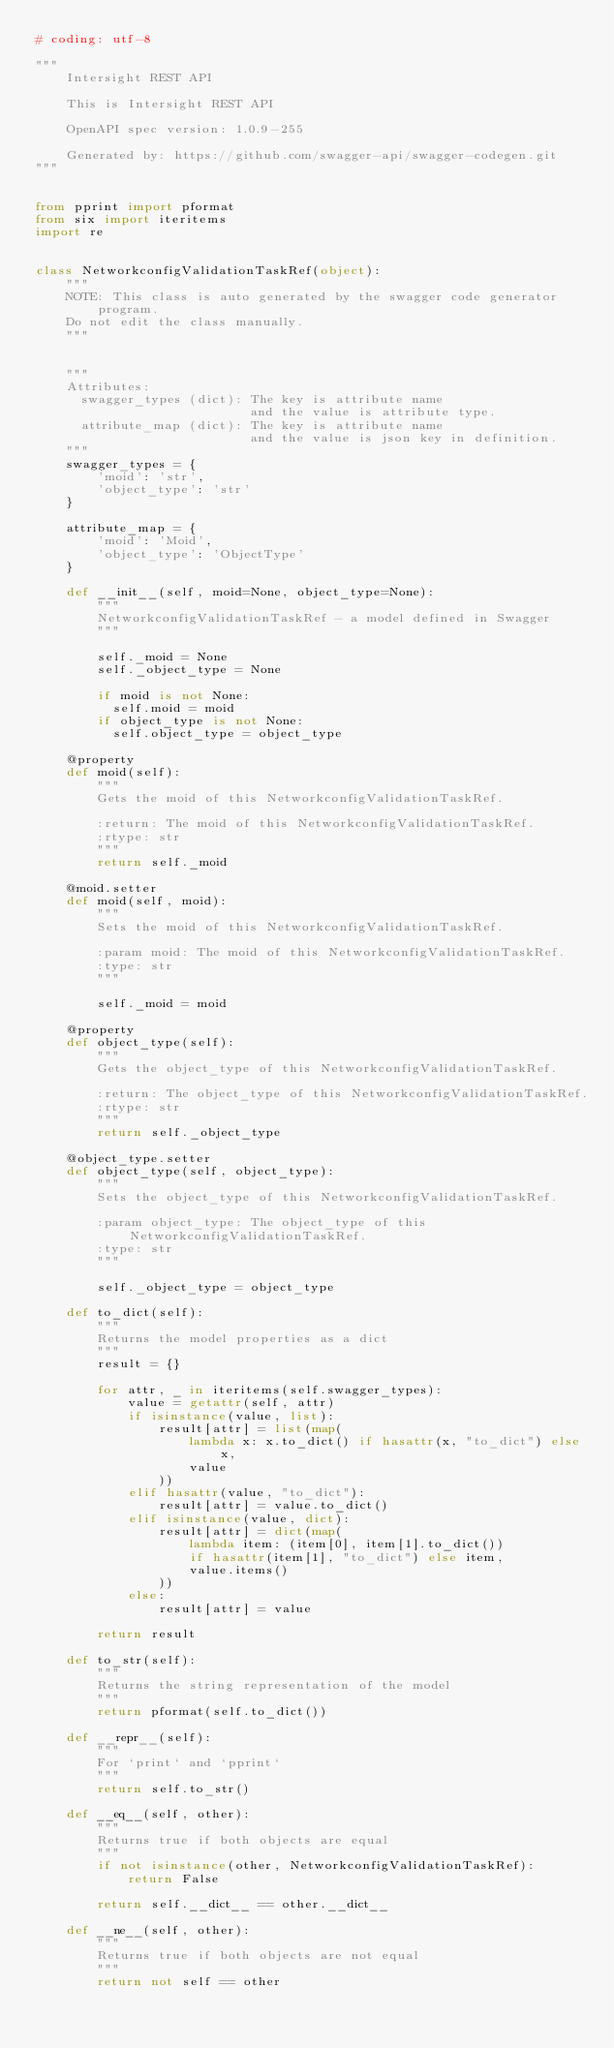Convert code to text. <code><loc_0><loc_0><loc_500><loc_500><_Python_># coding: utf-8

"""
    Intersight REST API

    This is Intersight REST API 

    OpenAPI spec version: 1.0.9-255
    
    Generated by: https://github.com/swagger-api/swagger-codegen.git
"""


from pprint import pformat
from six import iteritems
import re


class NetworkconfigValidationTaskRef(object):
    """
    NOTE: This class is auto generated by the swagger code generator program.
    Do not edit the class manually.
    """


    """
    Attributes:
      swagger_types (dict): The key is attribute name
                            and the value is attribute type.
      attribute_map (dict): The key is attribute name
                            and the value is json key in definition.
    """
    swagger_types = {
        'moid': 'str',
        'object_type': 'str'
    }

    attribute_map = {
        'moid': 'Moid',
        'object_type': 'ObjectType'
    }

    def __init__(self, moid=None, object_type=None):
        """
        NetworkconfigValidationTaskRef - a model defined in Swagger
        """

        self._moid = None
        self._object_type = None

        if moid is not None:
          self.moid = moid
        if object_type is not None:
          self.object_type = object_type

    @property
    def moid(self):
        """
        Gets the moid of this NetworkconfigValidationTaskRef.

        :return: The moid of this NetworkconfigValidationTaskRef.
        :rtype: str
        """
        return self._moid

    @moid.setter
    def moid(self, moid):
        """
        Sets the moid of this NetworkconfigValidationTaskRef.

        :param moid: The moid of this NetworkconfigValidationTaskRef.
        :type: str
        """

        self._moid = moid

    @property
    def object_type(self):
        """
        Gets the object_type of this NetworkconfigValidationTaskRef.

        :return: The object_type of this NetworkconfigValidationTaskRef.
        :rtype: str
        """
        return self._object_type

    @object_type.setter
    def object_type(self, object_type):
        """
        Sets the object_type of this NetworkconfigValidationTaskRef.

        :param object_type: The object_type of this NetworkconfigValidationTaskRef.
        :type: str
        """

        self._object_type = object_type

    def to_dict(self):
        """
        Returns the model properties as a dict
        """
        result = {}

        for attr, _ in iteritems(self.swagger_types):
            value = getattr(self, attr)
            if isinstance(value, list):
                result[attr] = list(map(
                    lambda x: x.to_dict() if hasattr(x, "to_dict") else x,
                    value
                ))
            elif hasattr(value, "to_dict"):
                result[attr] = value.to_dict()
            elif isinstance(value, dict):
                result[attr] = dict(map(
                    lambda item: (item[0], item[1].to_dict())
                    if hasattr(item[1], "to_dict") else item,
                    value.items()
                ))
            else:
                result[attr] = value

        return result

    def to_str(self):
        """
        Returns the string representation of the model
        """
        return pformat(self.to_dict())

    def __repr__(self):
        """
        For `print` and `pprint`
        """
        return self.to_str()

    def __eq__(self, other):
        """
        Returns true if both objects are equal
        """
        if not isinstance(other, NetworkconfigValidationTaskRef):
            return False

        return self.__dict__ == other.__dict__

    def __ne__(self, other):
        """
        Returns true if both objects are not equal
        """
        return not self == other
</code> 